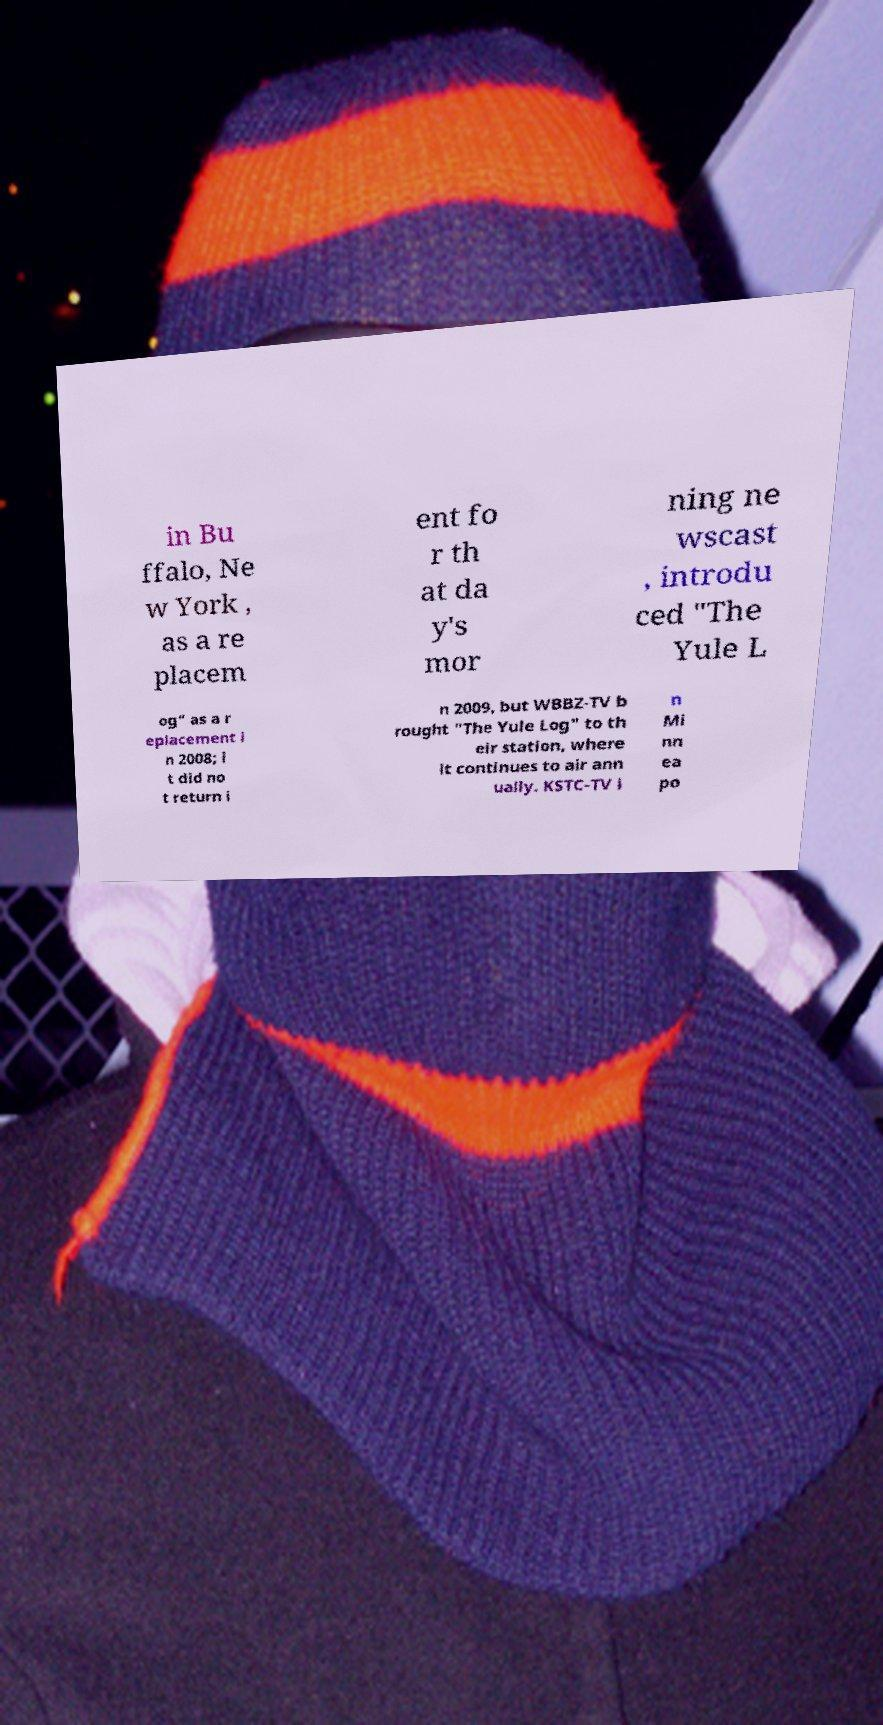What messages or text are displayed in this image? I need them in a readable, typed format. in Bu ffalo, Ne w York , as a re placem ent fo r th at da y's mor ning ne wscast , introdu ced "The Yule L og" as a r eplacement i n 2008; i t did no t return i n 2009, but WBBZ-TV b rought "The Yule Log" to th eir station, where it continues to air ann ually. KSTC-TV i n Mi nn ea po 